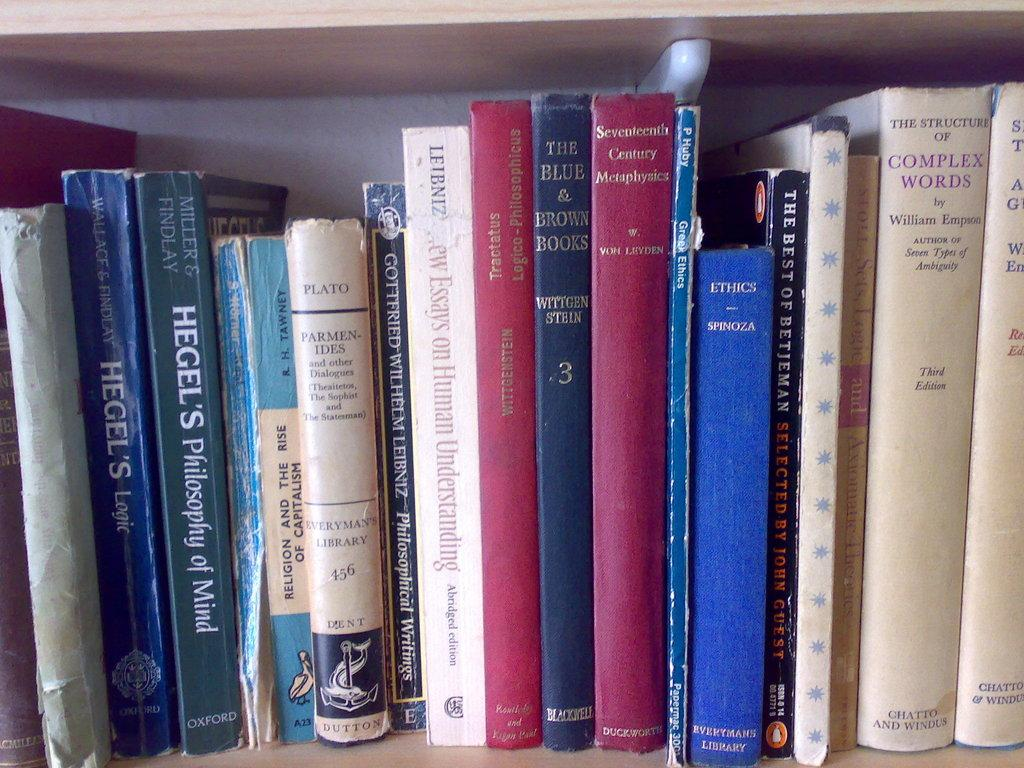What type of items can be seen in the wooden shelf? There are books in the wooden shelf. Is there anything else attached to the wooden shelf besides the books? Yes, there is an object attached to the wooden shelf. What type of rod can be seen holding up the underwear in the image? There is no rod or underwear present in the image. 